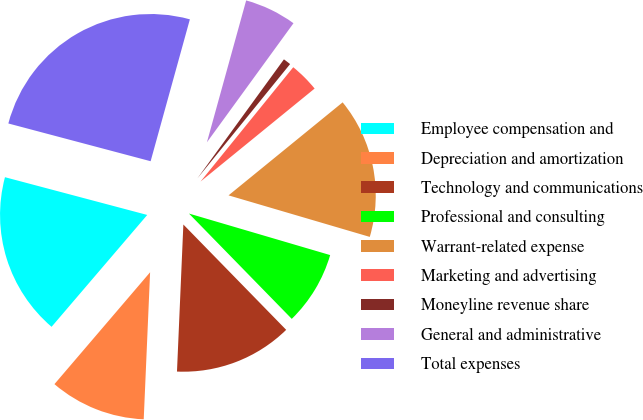Convert chart to OTSL. <chart><loc_0><loc_0><loc_500><loc_500><pie_chart><fcel>Employee compensation and<fcel>Depreciation and amortization<fcel>Technology and communications<fcel>Professional and consulting<fcel>Warrant-related expense<fcel>Marketing and advertising<fcel>Moneyline revenue share<fcel>General and administrative<fcel>Total expenses<nl><fcel>17.87%<fcel>10.57%<fcel>13.0%<fcel>8.14%<fcel>15.44%<fcel>3.27%<fcel>0.84%<fcel>5.71%<fcel>25.17%<nl></chart> 